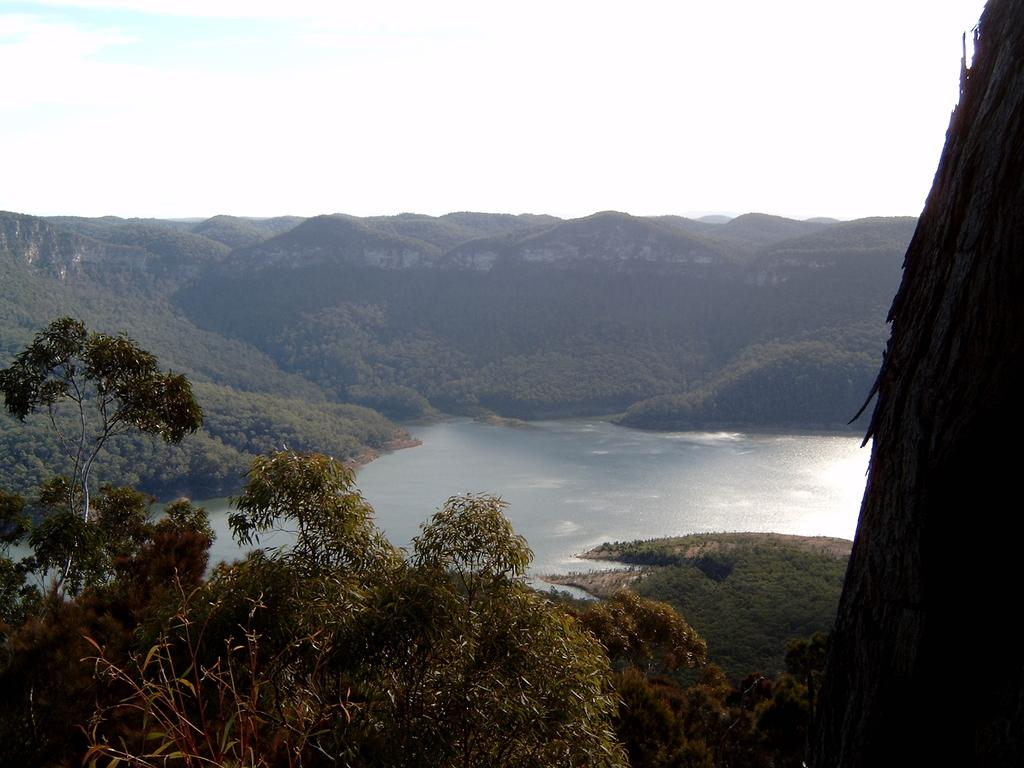What type of natural landform can be seen in the image? There are mountains in the image. What other natural elements are present in the image? There are trees and water visible in the image. How would you describe the sky in the image? The sky is a combination of white and blue colors. Can you see an airplane flying over the mountains in the image? There is no airplane visible in the image. Is there a record player present in the image? There is no record player mentioned or visible in the image. 